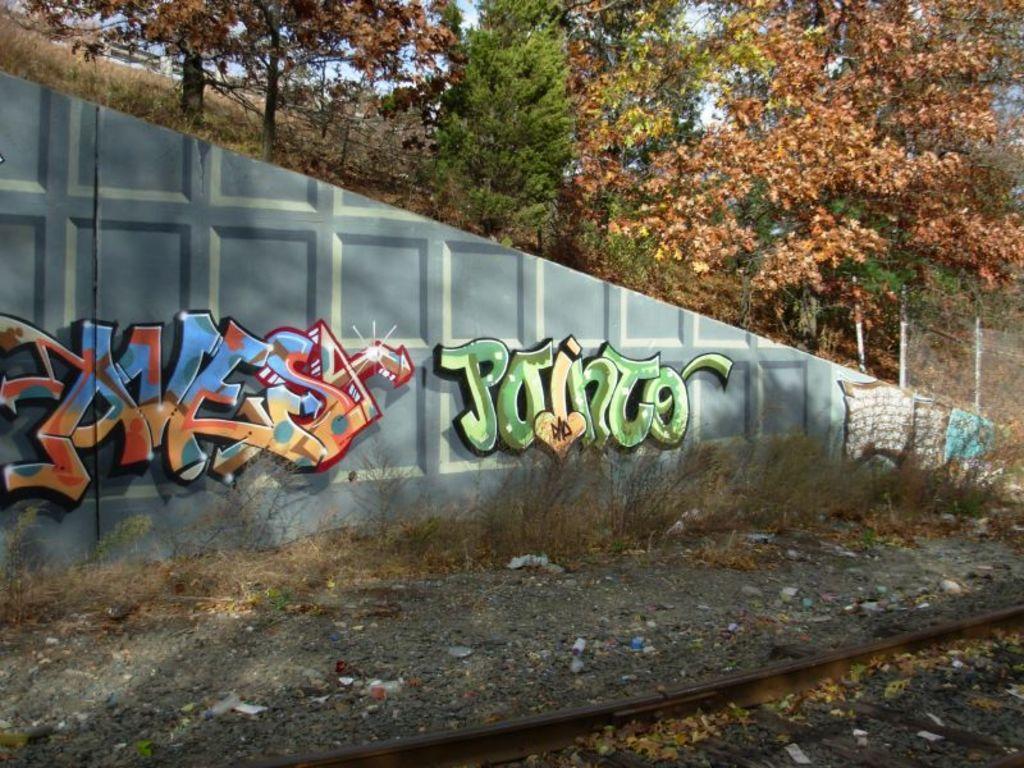In one or two sentences, can you explain what this image depicts? In this image I can see a brown colour railway track in the front. In the background I can see the wall, grass, number of trees and on the wall I can see something is written. I can also see number of things on the ground. 